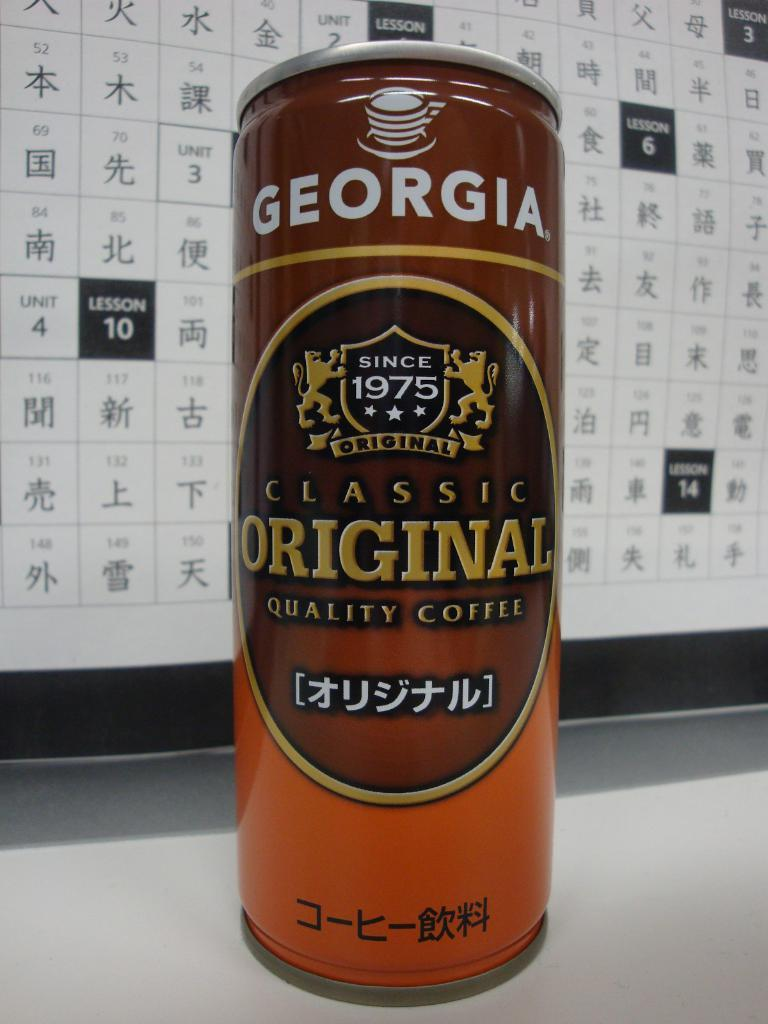<image>
Render a clear and concise summary of the photo. a can of georgia classic original quality coffee in front of a board 